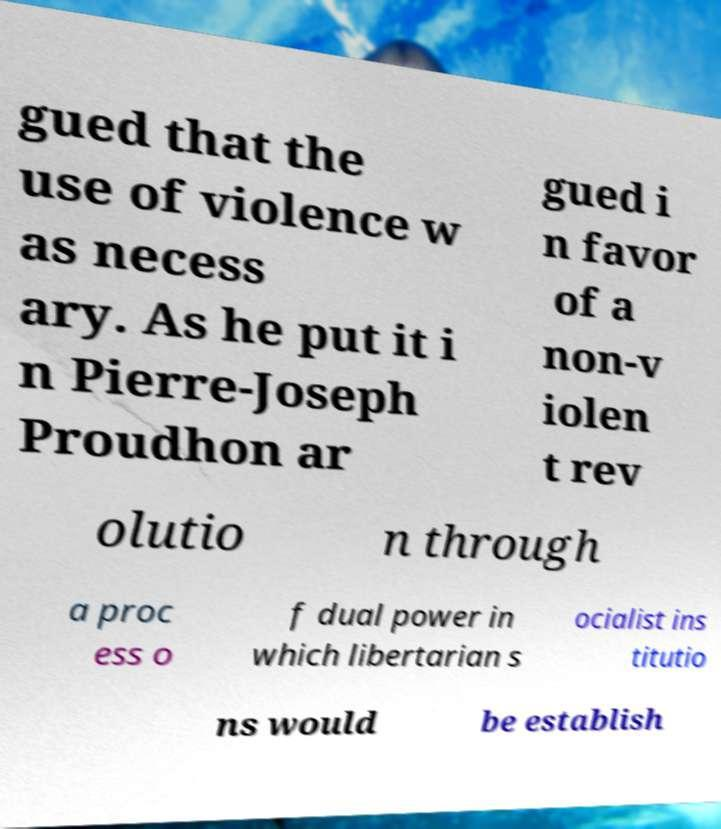Could you assist in decoding the text presented in this image and type it out clearly? gued that the use of violence w as necess ary. As he put it i n Pierre-Joseph Proudhon ar gued i n favor of a non-v iolen t rev olutio n through a proc ess o f dual power in which libertarian s ocialist ins titutio ns would be establish 